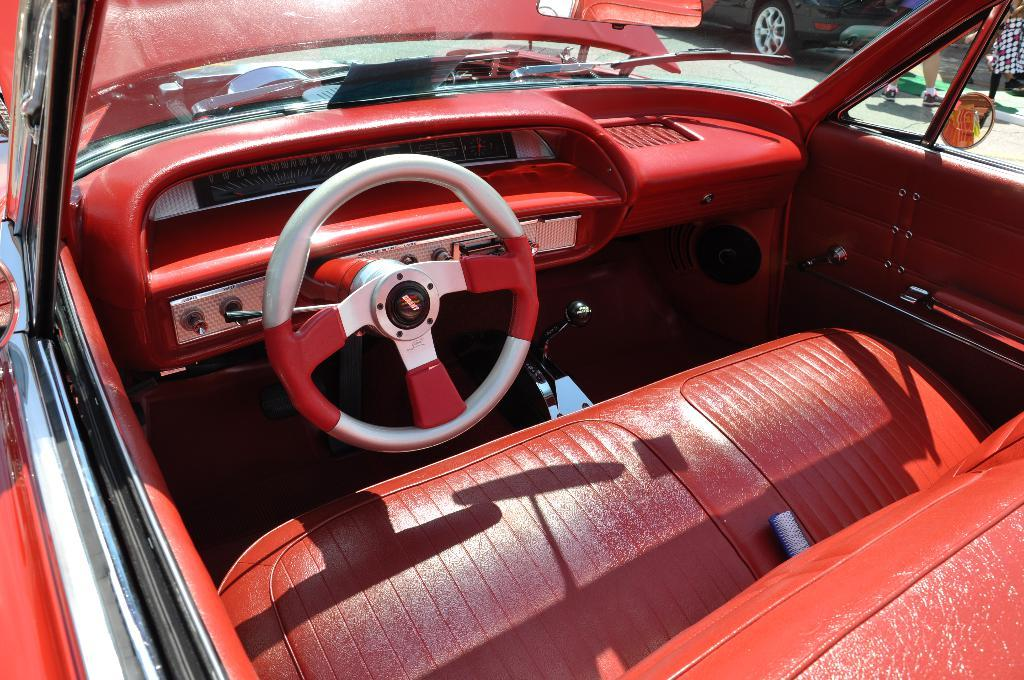What is the main subject in the center of the image? There is a car in the center of the image. What color is the car? The car is red in color. Are there any other cars in the image? Yes, there is another car in the image. Where are the people located in the image? The people are at the top side of the image. What type of crown is being worn by the people at the top side of the image? There is no crown present in the image; the people are not wearing any headgear. 